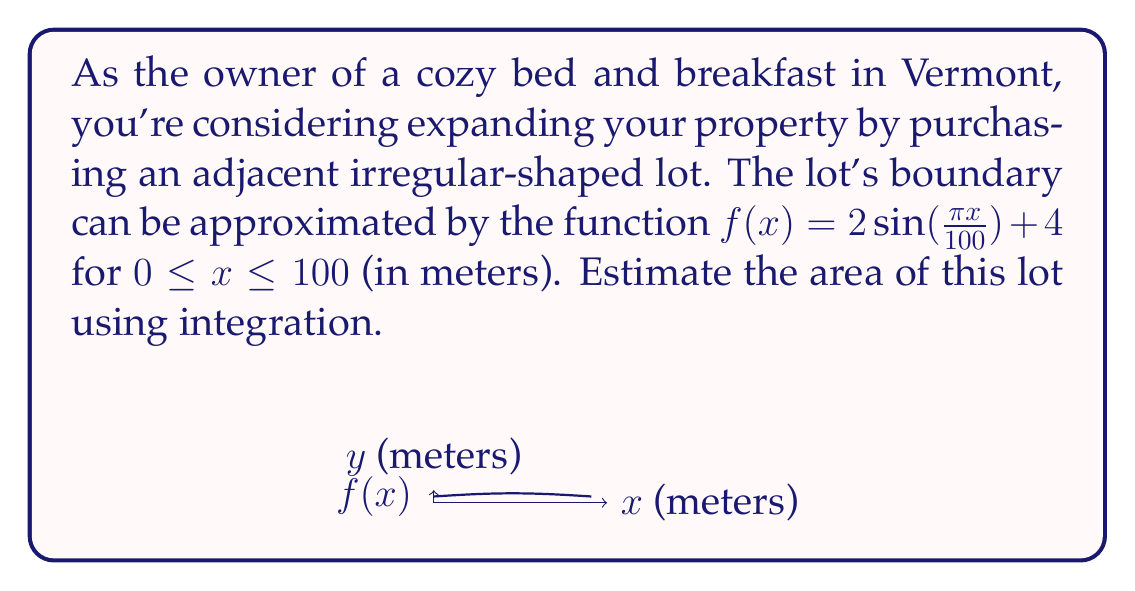Provide a solution to this math problem. To estimate the area of the irregular-shaped lot, we need to integrate the function $f(x)$ over the given interval. The area under the curve represents the lot's area.

1) The function is $f(x) = 2\sin(\frac{\pi x}{100}) + 4$ for $0 \leq x \leq 100$.

2) The area is given by the definite integral:

   $$A = \int_0^{100} f(x) dx = \int_0^{100} (2\sin(\frac{\pi x}{100}) + 4) dx$$

3) Let's break this into two integrals:

   $$A = \int_0^{100} 2\sin(\frac{\pi x}{100}) dx + \int_0^{100} 4 dx$$

4) For the first integral, let $u = \frac{\pi x}{100}$, then $du = \frac{\pi}{100} dx$ and $dx = \frac{100}{\pi} du$:

   $$\int_0^{100} 2\sin(\frac{\pi x}{100}) dx = \frac{200}{\pi} \int_0^{\pi} \sin(u) du = \frac{200}{\pi} [-\cos(u)]_0^{\pi} = \frac{400}{\pi}$$

5) The second integral is straightforward:

   $$\int_0^{100} 4 dx = 4x \Big|_0^{100} = 400$$

6) Adding the results:

   $$A = \frac{400}{\pi} + 400 = 400(\frac{1}{\pi} + 1) \approx 527.32 \text{ square meters}$$
Answer: The estimated area of the irregular-shaped lot is approximately 527.32 square meters. 